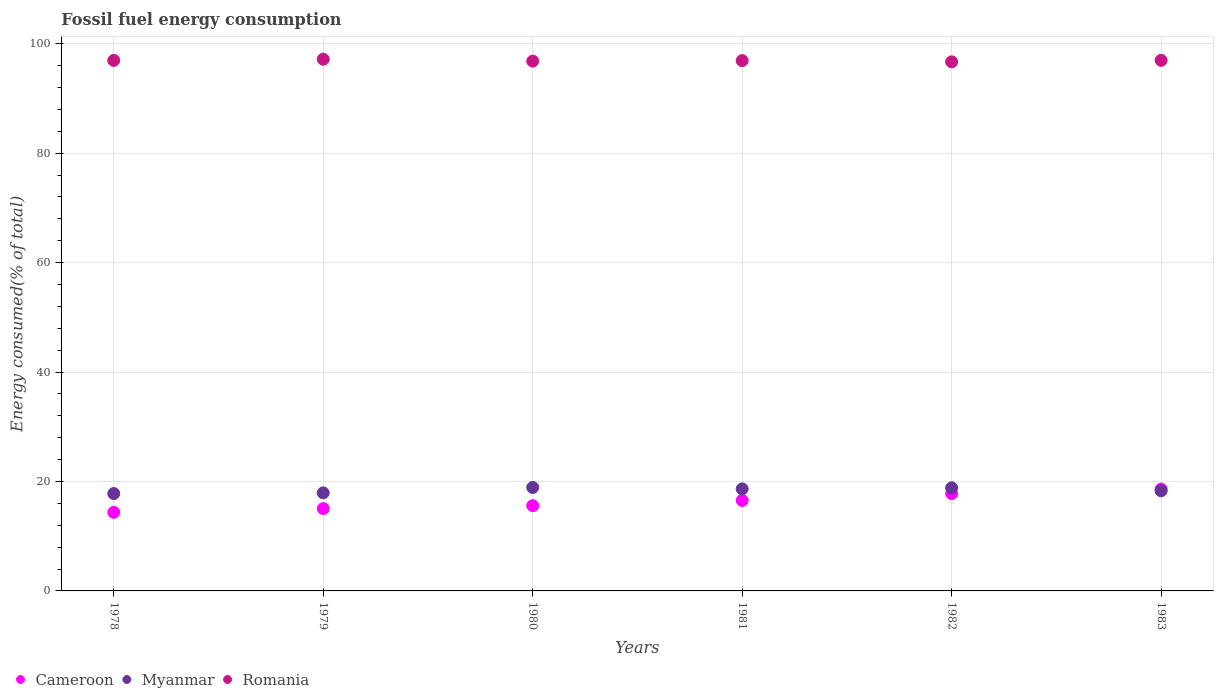How many different coloured dotlines are there?
Your answer should be compact. 3. Is the number of dotlines equal to the number of legend labels?
Provide a succinct answer. Yes. What is the percentage of energy consumed in Myanmar in 1978?
Provide a succinct answer. 17.79. Across all years, what is the maximum percentage of energy consumed in Romania?
Offer a very short reply. 97.16. Across all years, what is the minimum percentage of energy consumed in Cameroon?
Keep it short and to the point. 14.36. In which year was the percentage of energy consumed in Myanmar maximum?
Make the answer very short. 1980. What is the total percentage of energy consumed in Romania in the graph?
Give a very brief answer. 581.48. What is the difference between the percentage of energy consumed in Romania in 1981 and that in 1982?
Offer a very short reply. 0.22. What is the difference between the percentage of energy consumed in Romania in 1979 and the percentage of energy consumed in Myanmar in 1980?
Provide a short and direct response. 78.26. What is the average percentage of energy consumed in Myanmar per year?
Provide a succinct answer. 18.4. In the year 1978, what is the difference between the percentage of energy consumed in Cameroon and percentage of energy consumed in Romania?
Your answer should be very brief. -82.59. In how many years, is the percentage of energy consumed in Cameroon greater than 64 %?
Ensure brevity in your answer.  0. What is the ratio of the percentage of energy consumed in Myanmar in 1980 to that in 1983?
Make the answer very short. 1.03. Is the difference between the percentage of energy consumed in Cameroon in 1979 and 1982 greater than the difference between the percentage of energy consumed in Romania in 1979 and 1982?
Offer a terse response. No. What is the difference between the highest and the second highest percentage of energy consumed in Myanmar?
Your answer should be very brief. 0.06. What is the difference between the highest and the lowest percentage of energy consumed in Romania?
Make the answer very short. 0.48. Is it the case that in every year, the sum of the percentage of energy consumed in Romania and percentage of energy consumed in Cameroon  is greater than the percentage of energy consumed in Myanmar?
Provide a succinct answer. Yes. Is the percentage of energy consumed in Myanmar strictly greater than the percentage of energy consumed in Romania over the years?
Provide a short and direct response. No. Is the percentage of energy consumed in Cameroon strictly less than the percentage of energy consumed in Romania over the years?
Make the answer very short. Yes. Are the values on the major ticks of Y-axis written in scientific E-notation?
Keep it short and to the point. No. Does the graph contain grids?
Make the answer very short. Yes. How are the legend labels stacked?
Keep it short and to the point. Horizontal. What is the title of the graph?
Offer a very short reply. Fossil fuel energy consumption. What is the label or title of the X-axis?
Provide a succinct answer. Years. What is the label or title of the Y-axis?
Offer a terse response. Energy consumed(% of total). What is the Energy consumed(% of total) in Cameroon in 1978?
Give a very brief answer. 14.36. What is the Energy consumed(% of total) of Myanmar in 1978?
Give a very brief answer. 17.79. What is the Energy consumed(% of total) of Romania in 1978?
Your response must be concise. 96.95. What is the Energy consumed(% of total) in Cameroon in 1979?
Your answer should be very brief. 15.04. What is the Energy consumed(% of total) in Myanmar in 1979?
Provide a short and direct response. 17.92. What is the Energy consumed(% of total) of Romania in 1979?
Provide a succinct answer. 97.16. What is the Energy consumed(% of total) in Cameroon in 1980?
Offer a terse response. 15.57. What is the Energy consumed(% of total) of Myanmar in 1980?
Your answer should be very brief. 18.91. What is the Energy consumed(% of total) in Romania in 1980?
Make the answer very short. 96.81. What is the Energy consumed(% of total) in Cameroon in 1981?
Provide a succinct answer. 16.53. What is the Energy consumed(% of total) of Myanmar in 1981?
Make the answer very short. 18.65. What is the Energy consumed(% of total) in Romania in 1981?
Make the answer very short. 96.91. What is the Energy consumed(% of total) of Cameroon in 1982?
Provide a short and direct response. 17.77. What is the Energy consumed(% of total) in Myanmar in 1982?
Offer a very short reply. 18.84. What is the Energy consumed(% of total) of Romania in 1982?
Ensure brevity in your answer.  96.69. What is the Energy consumed(% of total) of Cameroon in 1983?
Keep it short and to the point. 18.61. What is the Energy consumed(% of total) of Myanmar in 1983?
Give a very brief answer. 18.29. What is the Energy consumed(% of total) of Romania in 1983?
Offer a terse response. 96.96. Across all years, what is the maximum Energy consumed(% of total) of Cameroon?
Give a very brief answer. 18.61. Across all years, what is the maximum Energy consumed(% of total) in Myanmar?
Your response must be concise. 18.91. Across all years, what is the maximum Energy consumed(% of total) in Romania?
Your answer should be compact. 97.16. Across all years, what is the minimum Energy consumed(% of total) in Cameroon?
Your answer should be compact. 14.36. Across all years, what is the minimum Energy consumed(% of total) of Myanmar?
Provide a succinct answer. 17.79. Across all years, what is the minimum Energy consumed(% of total) in Romania?
Offer a terse response. 96.69. What is the total Energy consumed(% of total) of Cameroon in the graph?
Keep it short and to the point. 97.88. What is the total Energy consumed(% of total) in Myanmar in the graph?
Make the answer very short. 110.4. What is the total Energy consumed(% of total) of Romania in the graph?
Offer a terse response. 581.48. What is the difference between the Energy consumed(% of total) in Cameroon in 1978 and that in 1979?
Offer a terse response. -0.68. What is the difference between the Energy consumed(% of total) of Myanmar in 1978 and that in 1979?
Your answer should be very brief. -0.13. What is the difference between the Energy consumed(% of total) in Romania in 1978 and that in 1979?
Your response must be concise. -0.21. What is the difference between the Energy consumed(% of total) of Cameroon in 1978 and that in 1980?
Offer a very short reply. -1.22. What is the difference between the Energy consumed(% of total) of Myanmar in 1978 and that in 1980?
Your answer should be compact. -1.11. What is the difference between the Energy consumed(% of total) in Romania in 1978 and that in 1980?
Offer a terse response. 0.14. What is the difference between the Energy consumed(% of total) of Cameroon in 1978 and that in 1981?
Your answer should be compact. -2.17. What is the difference between the Energy consumed(% of total) of Myanmar in 1978 and that in 1981?
Your answer should be very brief. -0.86. What is the difference between the Energy consumed(% of total) in Romania in 1978 and that in 1981?
Give a very brief answer. 0.04. What is the difference between the Energy consumed(% of total) in Cameroon in 1978 and that in 1982?
Keep it short and to the point. -3.41. What is the difference between the Energy consumed(% of total) of Myanmar in 1978 and that in 1982?
Keep it short and to the point. -1.05. What is the difference between the Energy consumed(% of total) of Romania in 1978 and that in 1982?
Give a very brief answer. 0.26. What is the difference between the Energy consumed(% of total) of Cameroon in 1978 and that in 1983?
Your answer should be compact. -4.25. What is the difference between the Energy consumed(% of total) in Myanmar in 1978 and that in 1983?
Your answer should be compact. -0.5. What is the difference between the Energy consumed(% of total) in Romania in 1978 and that in 1983?
Ensure brevity in your answer.  -0.01. What is the difference between the Energy consumed(% of total) in Cameroon in 1979 and that in 1980?
Keep it short and to the point. -0.53. What is the difference between the Energy consumed(% of total) in Myanmar in 1979 and that in 1980?
Offer a very short reply. -0.99. What is the difference between the Energy consumed(% of total) of Romania in 1979 and that in 1980?
Your answer should be compact. 0.35. What is the difference between the Energy consumed(% of total) in Cameroon in 1979 and that in 1981?
Give a very brief answer. -1.49. What is the difference between the Energy consumed(% of total) in Myanmar in 1979 and that in 1981?
Make the answer very short. -0.73. What is the difference between the Energy consumed(% of total) of Romania in 1979 and that in 1981?
Provide a short and direct response. 0.26. What is the difference between the Energy consumed(% of total) of Cameroon in 1979 and that in 1982?
Your response must be concise. -2.73. What is the difference between the Energy consumed(% of total) of Myanmar in 1979 and that in 1982?
Offer a terse response. -0.92. What is the difference between the Energy consumed(% of total) of Romania in 1979 and that in 1982?
Offer a terse response. 0.48. What is the difference between the Energy consumed(% of total) of Cameroon in 1979 and that in 1983?
Keep it short and to the point. -3.57. What is the difference between the Energy consumed(% of total) in Myanmar in 1979 and that in 1983?
Provide a short and direct response. -0.37. What is the difference between the Energy consumed(% of total) in Romania in 1979 and that in 1983?
Ensure brevity in your answer.  0.2. What is the difference between the Energy consumed(% of total) in Cameroon in 1980 and that in 1981?
Your answer should be compact. -0.96. What is the difference between the Energy consumed(% of total) of Myanmar in 1980 and that in 1981?
Provide a short and direct response. 0.26. What is the difference between the Energy consumed(% of total) of Romania in 1980 and that in 1981?
Give a very brief answer. -0.09. What is the difference between the Energy consumed(% of total) of Cameroon in 1980 and that in 1982?
Give a very brief answer. -2.2. What is the difference between the Energy consumed(% of total) of Myanmar in 1980 and that in 1982?
Ensure brevity in your answer.  0.06. What is the difference between the Energy consumed(% of total) in Romania in 1980 and that in 1982?
Keep it short and to the point. 0.13. What is the difference between the Energy consumed(% of total) in Cameroon in 1980 and that in 1983?
Offer a terse response. -3.04. What is the difference between the Energy consumed(% of total) in Myanmar in 1980 and that in 1983?
Keep it short and to the point. 0.62. What is the difference between the Energy consumed(% of total) in Romania in 1980 and that in 1983?
Your response must be concise. -0.15. What is the difference between the Energy consumed(% of total) in Cameroon in 1981 and that in 1982?
Offer a very short reply. -1.24. What is the difference between the Energy consumed(% of total) of Myanmar in 1981 and that in 1982?
Your answer should be compact. -0.19. What is the difference between the Energy consumed(% of total) of Romania in 1981 and that in 1982?
Offer a terse response. 0.22. What is the difference between the Energy consumed(% of total) of Cameroon in 1981 and that in 1983?
Make the answer very short. -2.08. What is the difference between the Energy consumed(% of total) in Myanmar in 1981 and that in 1983?
Make the answer very short. 0.36. What is the difference between the Energy consumed(% of total) in Romania in 1981 and that in 1983?
Keep it short and to the point. -0.05. What is the difference between the Energy consumed(% of total) in Cameroon in 1982 and that in 1983?
Your response must be concise. -0.84. What is the difference between the Energy consumed(% of total) of Myanmar in 1982 and that in 1983?
Your answer should be compact. 0.55. What is the difference between the Energy consumed(% of total) in Romania in 1982 and that in 1983?
Make the answer very short. -0.27. What is the difference between the Energy consumed(% of total) of Cameroon in 1978 and the Energy consumed(% of total) of Myanmar in 1979?
Give a very brief answer. -3.56. What is the difference between the Energy consumed(% of total) in Cameroon in 1978 and the Energy consumed(% of total) in Romania in 1979?
Offer a very short reply. -82.81. What is the difference between the Energy consumed(% of total) in Myanmar in 1978 and the Energy consumed(% of total) in Romania in 1979?
Make the answer very short. -79.37. What is the difference between the Energy consumed(% of total) in Cameroon in 1978 and the Energy consumed(% of total) in Myanmar in 1980?
Make the answer very short. -4.55. What is the difference between the Energy consumed(% of total) in Cameroon in 1978 and the Energy consumed(% of total) in Romania in 1980?
Offer a terse response. -82.46. What is the difference between the Energy consumed(% of total) in Myanmar in 1978 and the Energy consumed(% of total) in Romania in 1980?
Give a very brief answer. -79.02. What is the difference between the Energy consumed(% of total) of Cameroon in 1978 and the Energy consumed(% of total) of Myanmar in 1981?
Your response must be concise. -4.29. What is the difference between the Energy consumed(% of total) in Cameroon in 1978 and the Energy consumed(% of total) in Romania in 1981?
Ensure brevity in your answer.  -82.55. What is the difference between the Energy consumed(% of total) of Myanmar in 1978 and the Energy consumed(% of total) of Romania in 1981?
Offer a terse response. -79.11. What is the difference between the Energy consumed(% of total) in Cameroon in 1978 and the Energy consumed(% of total) in Myanmar in 1982?
Provide a short and direct response. -4.49. What is the difference between the Energy consumed(% of total) in Cameroon in 1978 and the Energy consumed(% of total) in Romania in 1982?
Provide a short and direct response. -82.33. What is the difference between the Energy consumed(% of total) of Myanmar in 1978 and the Energy consumed(% of total) of Romania in 1982?
Give a very brief answer. -78.89. What is the difference between the Energy consumed(% of total) in Cameroon in 1978 and the Energy consumed(% of total) in Myanmar in 1983?
Ensure brevity in your answer.  -3.93. What is the difference between the Energy consumed(% of total) in Cameroon in 1978 and the Energy consumed(% of total) in Romania in 1983?
Make the answer very short. -82.6. What is the difference between the Energy consumed(% of total) in Myanmar in 1978 and the Energy consumed(% of total) in Romania in 1983?
Make the answer very short. -79.17. What is the difference between the Energy consumed(% of total) in Cameroon in 1979 and the Energy consumed(% of total) in Myanmar in 1980?
Offer a very short reply. -3.87. What is the difference between the Energy consumed(% of total) of Cameroon in 1979 and the Energy consumed(% of total) of Romania in 1980?
Offer a terse response. -81.77. What is the difference between the Energy consumed(% of total) of Myanmar in 1979 and the Energy consumed(% of total) of Romania in 1980?
Your answer should be compact. -78.89. What is the difference between the Energy consumed(% of total) in Cameroon in 1979 and the Energy consumed(% of total) in Myanmar in 1981?
Keep it short and to the point. -3.61. What is the difference between the Energy consumed(% of total) of Cameroon in 1979 and the Energy consumed(% of total) of Romania in 1981?
Offer a terse response. -81.87. What is the difference between the Energy consumed(% of total) of Myanmar in 1979 and the Energy consumed(% of total) of Romania in 1981?
Offer a terse response. -78.99. What is the difference between the Energy consumed(% of total) in Cameroon in 1979 and the Energy consumed(% of total) in Myanmar in 1982?
Offer a terse response. -3.8. What is the difference between the Energy consumed(% of total) in Cameroon in 1979 and the Energy consumed(% of total) in Romania in 1982?
Make the answer very short. -81.65. What is the difference between the Energy consumed(% of total) in Myanmar in 1979 and the Energy consumed(% of total) in Romania in 1982?
Ensure brevity in your answer.  -78.77. What is the difference between the Energy consumed(% of total) of Cameroon in 1979 and the Energy consumed(% of total) of Myanmar in 1983?
Your answer should be compact. -3.25. What is the difference between the Energy consumed(% of total) of Cameroon in 1979 and the Energy consumed(% of total) of Romania in 1983?
Ensure brevity in your answer.  -81.92. What is the difference between the Energy consumed(% of total) in Myanmar in 1979 and the Energy consumed(% of total) in Romania in 1983?
Your answer should be very brief. -79.04. What is the difference between the Energy consumed(% of total) of Cameroon in 1980 and the Energy consumed(% of total) of Myanmar in 1981?
Make the answer very short. -3.08. What is the difference between the Energy consumed(% of total) of Cameroon in 1980 and the Energy consumed(% of total) of Romania in 1981?
Offer a terse response. -81.33. What is the difference between the Energy consumed(% of total) in Myanmar in 1980 and the Energy consumed(% of total) in Romania in 1981?
Make the answer very short. -78. What is the difference between the Energy consumed(% of total) in Cameroon in 1980 and the Energy consumed(% of total) in Myanmar in 1982?
Make the answer very short. -3.27. What is the difference between the Energy consumed(% of total) of Cameroon in 1980 and the Energy consumed(% of total) of Romania in 1982?
Your response must be concise. -81.11. What is the difference between the Energy consumed(% of total) in Myanmar in 1980 and the Energy consumed(% of total) in Romania in 1982?
Your answer should be compact. -77.78. What is the difference between the Energy consumed(% of total) in Cameroon in 1980 and the Energy consumed(% of total) in Myanmar in 1983?
Give a very brief answer. -2.72. What is the difference between the Energy consumed(% of total) in Cameroon in 1980 and the Energy consumed(% of total) in Romania in 1983?
Offer a terse response. -81.39. What is the difference between the Energy consumed(% of total) in Myanmar in 1980 and the Energy consumed(% of total) in Romania in 1983?
Your answer should be compact. -78.05. What is the difference between the Energy consumed(% of total) of Cameroon in 1981 and the Energy consumed(% of total) of Myanmar in 1982?
Your answer should be very brief. -2.31. What is the difference between the Energy consumed(% of total) in Cameroon in 1981 and the Energy consumed(% of total) in Romania in 1982?
Keep it short and to the point. -80.16. What is the difference between the Energy consumed(% of total) of Myanmar in 1981 and the Energy consumed(% of total) of Romania in 1982?
Provide a short and direct response. -78.04. What is the difference between the Energy consumed(% of total) in Cameroon in 1981 and the Energy consumed(% of total) in Myanmar in 1983?
Offer a very short reply. -1.76. What is the difference between the Energy consumed(% of total) of Cameroon in 1981 and the Energy consumed(% of total) of Romania in 1983?
Keep it short and to the point. -80.43. What is the difference between the Energy consumed(% of total) in Myanmar in 1981 and the Energy consumed(% of total) in Romania in 1983?
Provide a succinct answer. -78.31. What is the difference between the Energy consumed(% of total) of Cameroon in 1982 and the Energy consumed(% of total) of Myanmar in 1983?
Provide a short and direct response. -0.52. What is the difference between the Energy consumed(% of total) in Cameroon in 1982 and the Energy consumed(% of total) in Romania in 1983?
Your answer should be very brief. -79.19. What is the difference between the Energy consumed(% of total) of Myanmar in 1982 and the Energy consumed(% of total) of Romania in 1983?
Give a very brief answer. -78.12. What is the average Energy consumed(% of total) of Cameroon per year?
Make the answer very short. 16.31. What is the average Energy consumed(% of total) of Myanmar per year?
Your answer should be compact. 18.4. What is the average Energy consumed(% of total) in Romania per year?
Your answer should be compact. 96.91. In the year 1978, what is the difference between the Energy consumed(% of total) in Cameroon and Energy consumed(% of total) in Myanmar?
Offer a terse response. -3.44. In the year 1978, what is the difference between the Energy consumed(% of total) of Cameroon and Energy consumed(% of total) of Romania?
Keep it short and to the point. -82.59. In the year 1978, what is the difference between the Energy consumed(% of total) of Myanmar and Energy consumed(% of total) of Romania?
Offer a very short reply. -79.16. In the year 1979, what is the difference between the Energy consumed(% of total) of Cameroon and Energy consumed(% of total) of Myanmar?
Offer a very short reply. -2.88. In the year 1979, what is the difference between the Energy consumed(% of total) of Cameroon and Energy consumed(% of total) of Romania?
Give a very brief answer. -82.12. In the year 1979, what is the difference between the Energy consumed(% of total) in Myanmar and Energy consumed(% of total) in Romania?
Your response must be concise. -79.24. In the year 1980, what is the difference between the Energy consumed(% of total) in Cameroon and Energy consumed(% of total) in Myanmar?
Your response must be concise. -3.33. In the year 1980, what is the difference between the Energy consumed(% of total) of Cameroon and Energy consumed(% of total) of Romania?
Keep it short and to the point. -81.24. In the year 1980, what is the difference between the Energy consumed(% of total) of Myanmar and Energy consumed(% of total) of Romania?
Give a very brief answer. -77.91. In the year 1981, what is the difference between the Energy consumed(% of total) of Cameroon and Energy consumed(% of total) of Myanmar?
Your answer should be very brief. -2.12. In the year 1981, what is the difference between the Energy consumed(% of total) of Cameroon and Energy consumed(% of total) of Romania?
Offer a terse response. -80.38. In the year 1981, what is the difference between the Energy consumed(% of total) in Myanmar and Energy consumed(% of total) in Romania?
Give a very brief answer. -78.26. In the year 1982, what is the difference between the Energy consumed(% of total) in Cameroon and Energy consumed(% of total) in Myanmar?
Make the answer very short. -1.07. In the year 1982, what is the difference between the Energy consumed(% of total) in Cameroon and Energy consumed(% of total) in Romania?
Your answer should be very brief. -78.92. In the year 1982, what is the difference between the Energy consumed(% of total) in Myanmar and Energy consumed(% of total) in Romania?
Keep it short and to the point. -77.84. In the year 1983, what is the difference between the Energy consumed(% of total) of Cameroon and Energy consumed(% of total) of Myanmar?
Your response must be concise. 0.32. In the year 1983, what is the difference between the Energy consumed(% of total) in Cameroon and Energy consumed(% of total) in Romania?
Offer a very short reply. -78.35. In the year 1983, what is the difference between the Energy consumed(% of total) in Myanmar and Energy consumed(% of total) in Romania?
Offer a very short reply. -78.67. What is the ratio of the Energy consumed(% of total) of Cameroon in 1978 to that in 1979?
Offer a terse response. 0.95. What is the ratio of the Energy consumed(% of total) of Cameroon in 1978 to that in 1980?
Give a very brief answer. 0.92. What is the ratio of the Energy consumed(% of total) of Myanmar in 1978 to that in 1980?
Provide a short and direct response. 0.94. What is the ratio of the Energy consumed(% of total) in Cameroon in 1978 to that in 1981?
Ensure brevity in your answer.  0.87. What is the ratio of the Energy consumed(% of total) in Myanmar in 1978 to that in 1981?
Your response must be concise. 0.95. What is the ratio of the Energy consumed(% of total) of Cameroon in 1978 to that in 1982?
Your answer should be compact. 0.81. What is the ratio of the Energy consumed(% of total) of Myanmar in 1978 to that in 1982?
Your answer should be very brief. 0.94. What is the ratio of the Energy consumed(% of total) in Romania in 1978 to that in 1982?
Your answer should be compact. 1. What is the ratio of the Energy consumed(% of total) of Cameroon in 1978 to that in 1983?
Give a very brief answer. 0.77. What is the ratio of the Energy consumed(% of total) of Myanmar in 1978 to that in 1983?
Offer a terse response. 0.97. What is the ratio of the Energy consumed(% of total) of Cameroon in 1979 to that in 1980?
Offer a terse response. 0.97. What is the ratio of the Energy consumed(% of total) of Myanmar in 1979 to that in 1980?
Your response must be concise. 0.95. What is the ratio of the Energy consumed(% of total) of Cameroon in 1979 to that in 1981?
Offer a very short reply. 0.91. What is the ratio of the Energy consumed(% of total) of Myanmar in 1979 to that in 1981?
Offer a terse response. 0.96. What is the ratio of the Energy consumed(% of total) in Romania in 1979 to that in 1981?
Offer a terse response. 1. What is the ratio of the Energy consumed(% of total) of Cameroon in 1979 to that in 1982?
Your answer should be compact. 0.85. What is the ratio of the Energy consumed(% of total) in Myanmar in 1979 to that in 1982?
Keep it short and to the point. 0.95. What is the ratio of the Energy consumed(% of total) of Cameroon in 1979 to that in 1983?
Your response must be concise. 0.81. What is the ratio of the Energy consumed(% of total) in Myanmar in 1979 to that in 1983?
Provide a short and direct response. 0.98. What is the ratio of the Energy consumed(% of total) in Romania in 1979 to that in 1983?
Offer a very short reply. 1. What is the ratio of the Energy consumed(% of total) in Cameroon in 1980 to that in 1981?
Offer a terse response. 0.94. What is the ratio of the Energy consumed(% of total) of Myanmar in 1980 to that in 1981?
Offer a terse response. 1.01. What is the ratio of the Energy consumed(% of total) in Romania in 1980 to that in 1981?
Make the answer very short. 1. What is the ratio of the Energy consumed(% of total) of Cameroon in 1980 to that in 1982?
Offer a very short reply. 0.88. What is the ratio of the Energy consumed(% of total) of Romania in 1980 to that in 1982?
Ensure brevity in your answer.  1. What is the ratio of the Energy consumed(% of total) in Cameroon in 1980 to that in 1983?
Give a very brief answer. 0.84. What is the ratio of the Energy consumed(% of total) in Myanmar in 1980 to that in 1983?
Ensure brevity in your answer.  1.03. What is the ratio of the Energy consumed(% of total) of Romania in 1980 to that in 1983?
Ensure brevity in your answer.  1. What is the ratio of the Energy consumed(% of total) in Cameroon in 1981 to that in 1982?
Give a very brief answer. 0.93. What is the ratio of the Energy consumed(% of total) of Romania in 1981 to that in 1982?
Provide a short and direct response. 1. What is the ratio of the Energy consumed(% of total) in Cameroon in 1981 to that in 1983?
Your answer should be compact. 0.89. What is the ratio of the Energy consumed(% of total) in Myanmar in 1981 to that in 1983?
Keep it short and to the point. 1.02. What is the ratio of the Energy consumed(% of total) of Cameroon in 1982 to that in 1983?
Keep it short and to the point. 0.95. What is the ratio of the Energy consumed(% of total) of Myanmar in 1982 to that in 1983?
Your answer should be very brief. 1.03. What is the ratio of the Energy consumed(% of total) of Romania in 1982 to that in 1983?
Offer a very short reply. 1. What is the difference between the highest and the second highest Energy consumed(% of total) of Cameroon?
Give a very brief answer. 0.84. What is the difference between the highest and the second highest Energy consumed(% of total) in Myanmar?
Offer a terse response. 0.06. What is the difference between the highest and the second highest Energy consumed(% of total) in Romania?
Offer a terse response. 0.2. What is the difference between the highest and the lowest Energy consumed(% of total) in Cameroon?
Give a very brief answer. 4.25. What is the difference between the highest and the lowest Energy consumed(% of total) in Myanmar?
Give a very brief answer. 1.11. What is the difference between the highest and the lowest Energy consumed(% of total) of Romania?
Offer a very short reply. 0.48. 